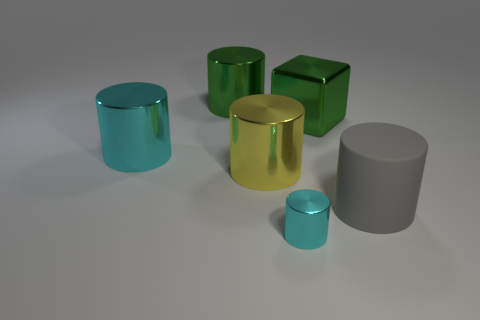How does the lighting affect the appearance of the objects? The lighting creates a soft ambiance, accentuating the reflective properties of the surfaces. It brings out the luster in the glossy materials, giving them a sense of depth and three-dimensionality. Shadows are subtly cast, suggesting a calm and diffuse light source that enhances the visual texture of the scene. 